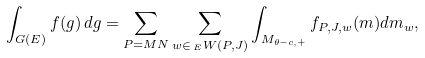Convert formula to latex. <formula><loc_0><loc_0><loc_500><loc_500>\int _ { G ( E ) } f ( g ) \, d g = \sum _ { P = M N } \sum _ { w \in \, _ { E } W ( P , J ) } \int _ { M _ { \theta - c , + } } f _ { P , J , w } ( m ) d m _ { w } ,</formula> 